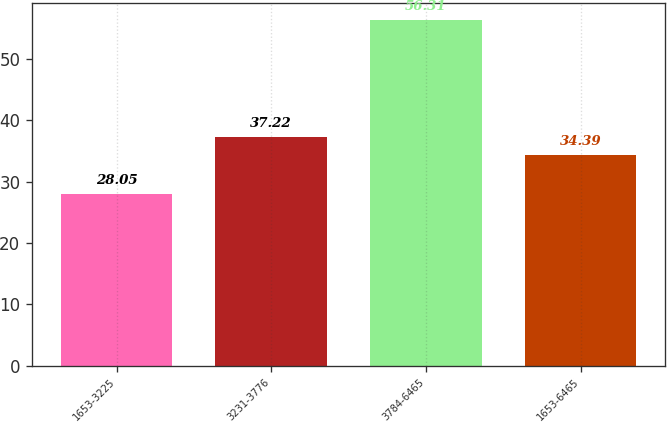Convert chart. <chart><loc_0><loc_0><loc_500><loc_500><bar_chart><fcel>1653-3225<fcel>3231-3776<fcel>3784-6465<fcel>1653-6465<nl><fcel>28.05<fcel>37.22<fcel>56.31<fcel>34.39<nl></chart> 